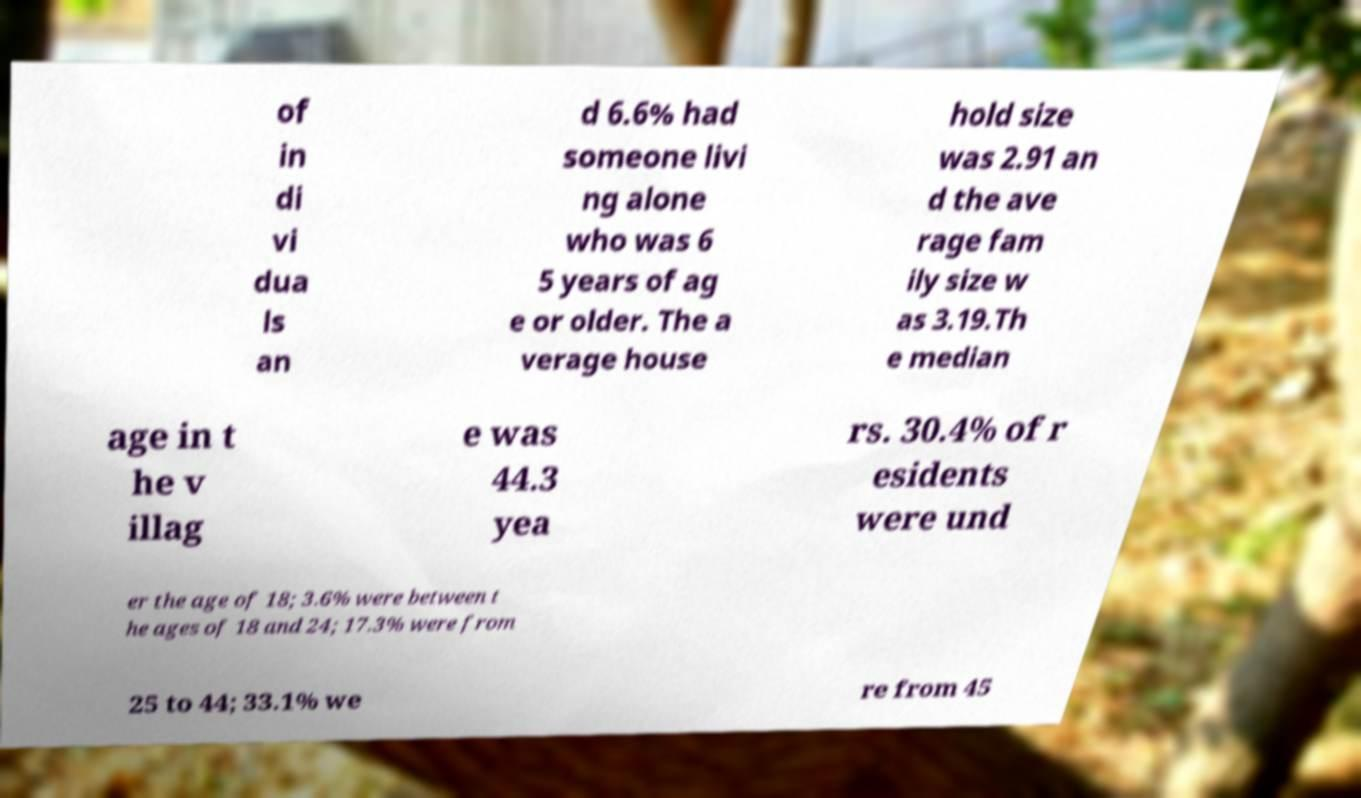Can you read and provide the text displayed in the image?This photo seems to have some interesting text. Can you extract and type it out for me? of in di vi dua ls an d 6.6% had someone livi ng alone who was 6 5 years of ag e or older. The a verage house hold size was 2.91 an d the ave rage fam ily size w as 3.19.Th e median age in t he v illag e was 44.3 yea rs. 30.4% of r esidents were und er the age of 18; 3.6% were between t he ages of 18 and 24; 17.3% were from 25 to 44; 33.1% we re from 45 